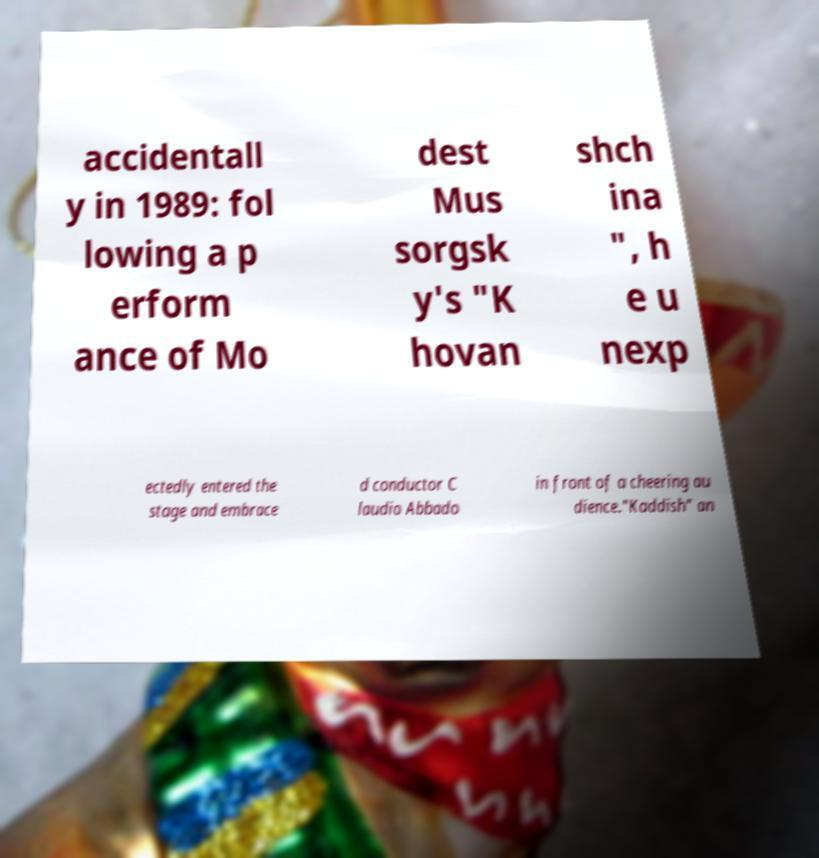Please read and relay the text visible in this image. What does it say? accidentall y in 1989: fol lowing a p erform ance of Mo dest Mus sorgsk y's "K hovan shch ina ", h e u nexp ectedly entered the stage and embrace d conductor C laudio Abbado in front of a cheering au dience."Kaddish" an 